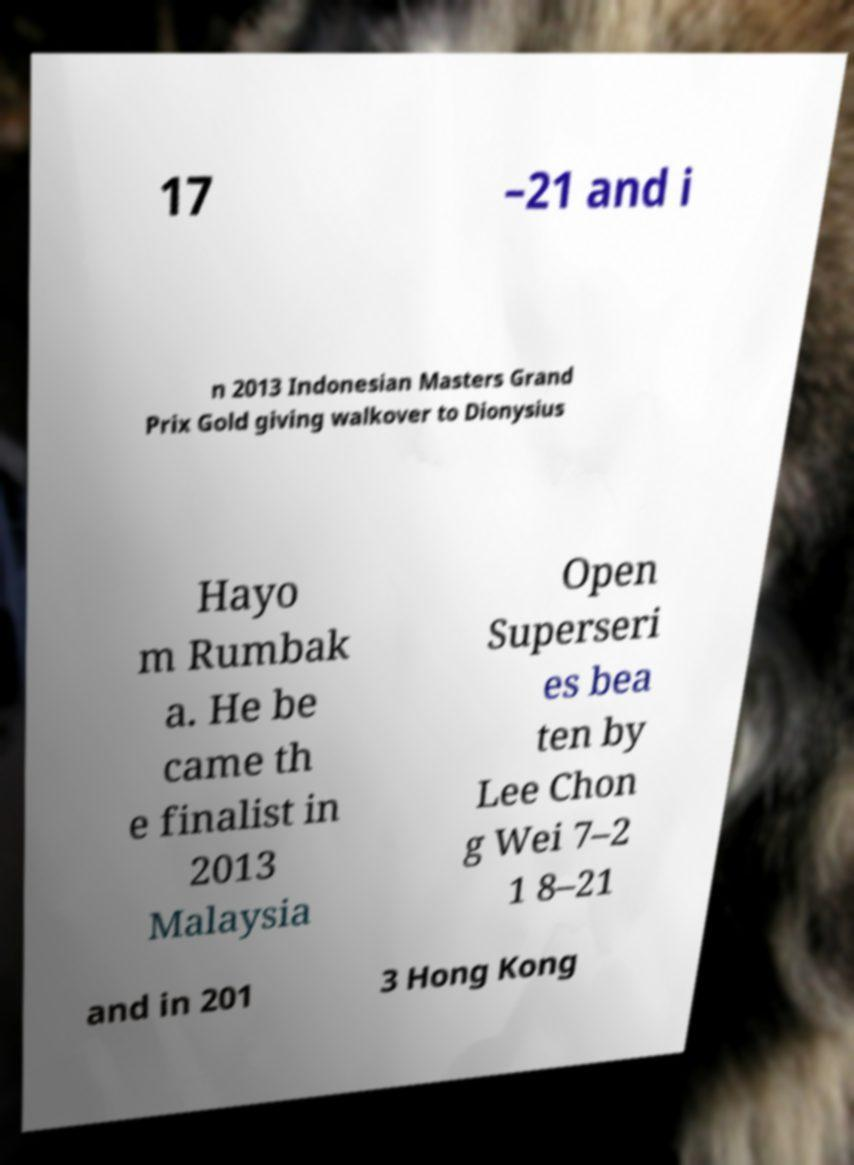Could you assist in decoding the text presented in this image and type it out clearly? 17 –21 and i n 2013 Indonesian Masters Grand Prix Gold giving walkover to Dionysius Hayo m Rumbak a. He be came th e finalist in 2013 Malaysia Open Superseri es bea ten by Lee Chon g Wei 7–2 1 8–21 and in 201 3 Hong Kong 